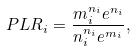Convert formula to latex. <formula><loc_0><loc_0><loc_500><loc_500>P L R _ { i } = \frac { m _ { i } ^ { n _ { i } } e ^ { n _ { i } } } { n _ { i } ^ { n _ { i } } e ^ { m _ { i } } } ,</formula> 